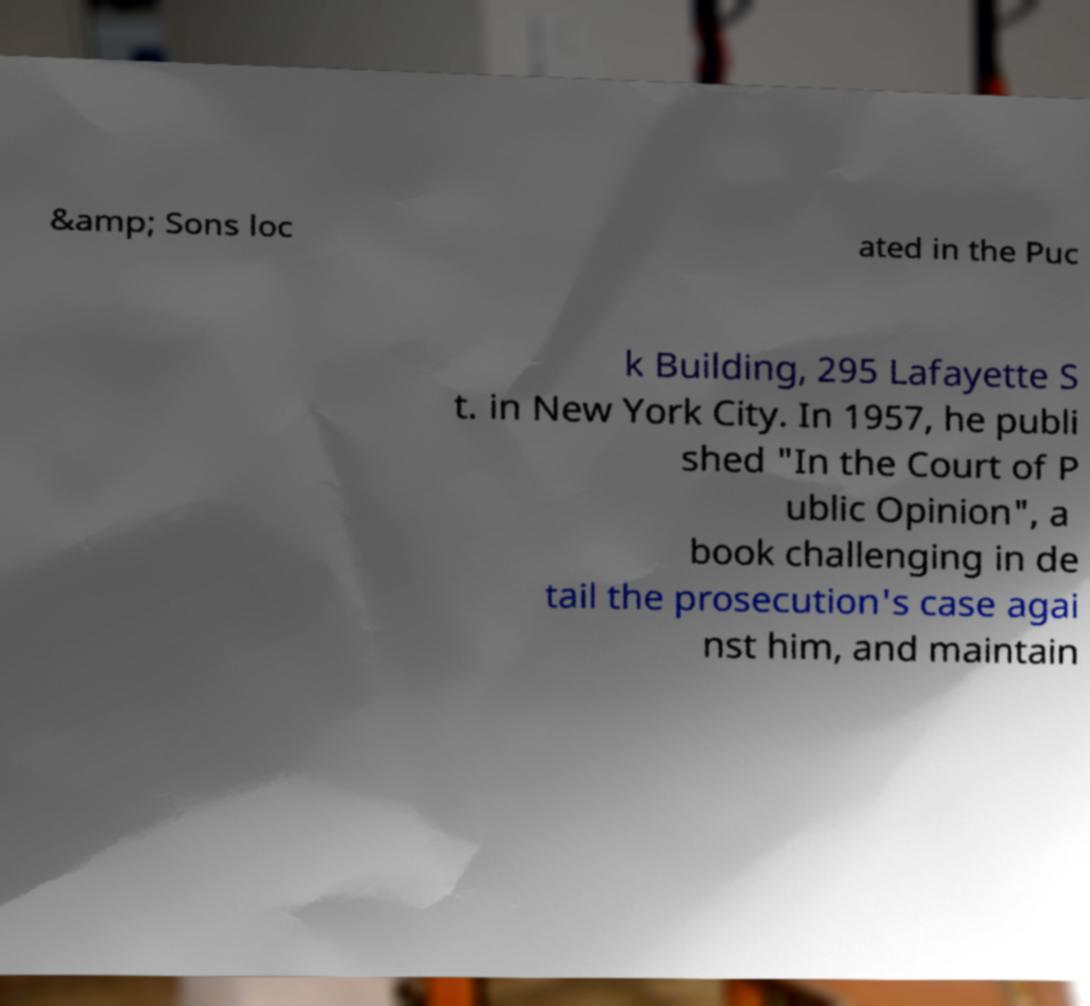There's text embedded in this image that I need extracted. Can you transcribe it verbatim? &amp; Sons loc ated in the Puc k Building, 295 Lafayette S t. in New York City. In 1957, he publi shed "In the Court of P ublic Opinion", a book challenging in de tail the prosecution's case agai nst him, and maintain 